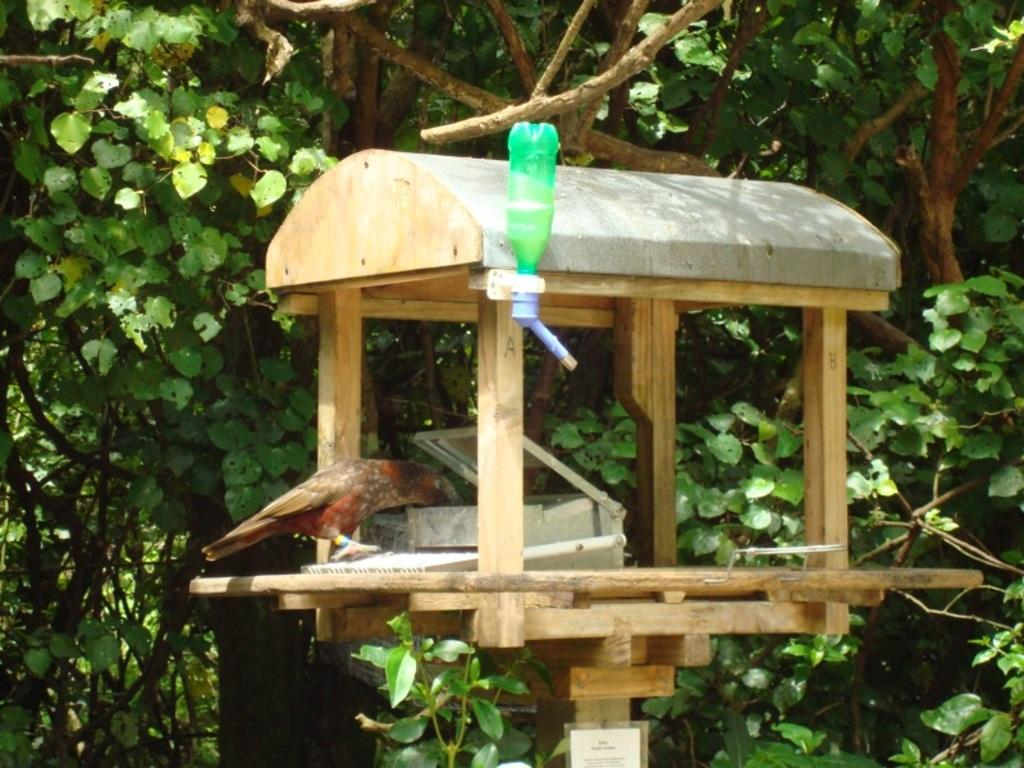What type of animal can be seen in the image? There is a bird in the image. What other objects are present in the image? There is a bottle, a box, and a board with text in the image. Can you describe the wooden object in the image? The wooden object resembles a bird house. What can be seen in the background of the image? There are trees in the background of the image. What type of meal is being prepared in the bird house in the image? There is no meal being prepared in the bird house in the image; it is a wooden structure for birds to use as shelter. 